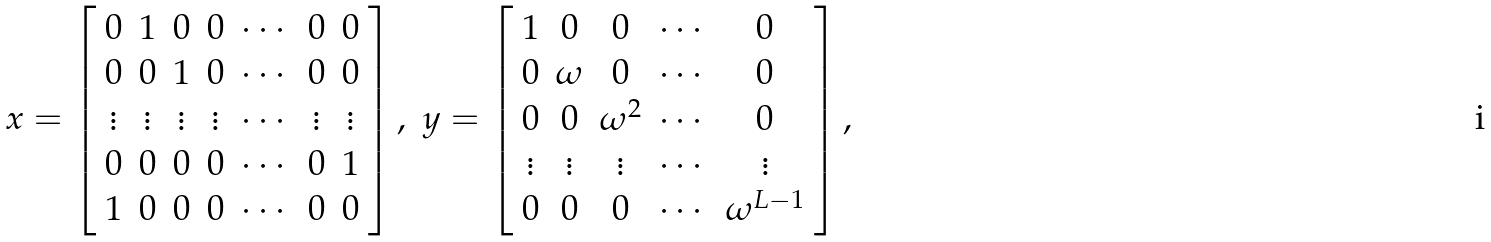Convert formula to latex. <formula><loc_0><loc_0><loc_500><loc_500>\begin{array} { c c } x = \left [ \begin{array} { c c c c c c c } 0 & 1 & 0 & 0 & \cdots & 0 & 0 \\ 0 & 0 & 1 & 0 & \cdots & 0 & 0 \\ \vdots & \vdots & \vdots & \vdots & \cdots & \vdots & \vdots \\ 0 & 0 & 0 & 0 & \cdots & 0 & 1 \\ 1 & 0 & 0 & 0 & \cdots & 0 & 0 \end{array} \right ] , & y = \left [ \begin{array} { c c c c c } 1 & 0 & 0 & \cdots & 0 \\ 0 & \omega & 0 & \cdots & 0 \\ 0 & 0 & \omega ^ { 2 } & \cdots & 0 \\ \vdots & \vdots & \vdots & \cdots & \vdots \\ 0 & 0 & 0 & \cdots & \omega ^ { L - 1 } \end{array} \right ] , \end{array}</formula> 